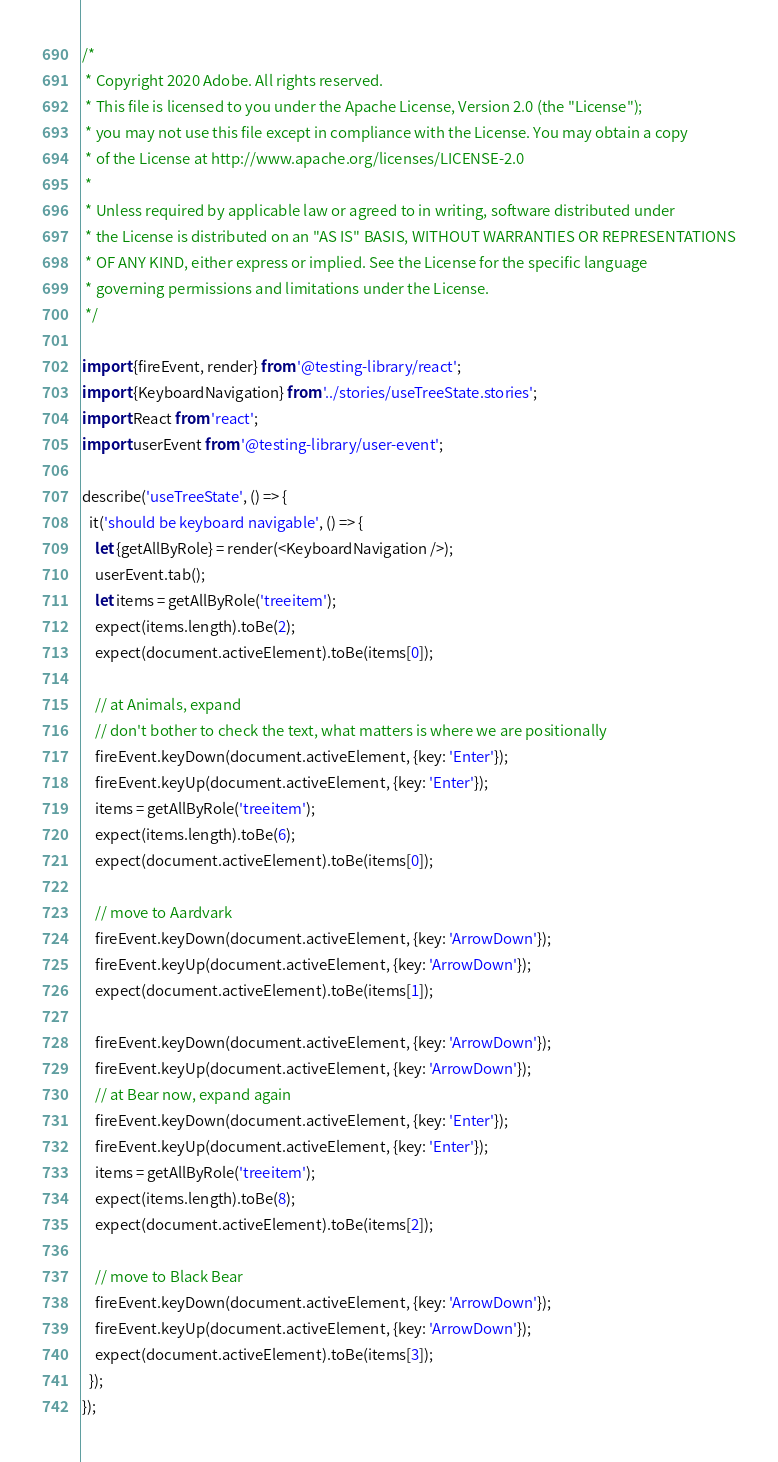Convert code to text. <code><loc_0><loc_0><loc_500><loc_500><_JavaScript_>/*
 * Copyright 2020 Adobe. All rights reserved.
 * This file is licensed to you under the Apache License, Version 2.0 (the "License");
 * you may not use this file except in compliance with the License. You may obtain a copy
 * of the License at http://www.apache.org/licenses/LICENSE-2.0
 *
 * Unless required by applicable law or agreed to in writing, software distributed under
 * the License is distributed on an "AS IS" BASIS, WITHOUT WARRANTIES OR REPRESENTATIONS
 * OF ANY KIND, either express or implied. See the License for the specific language
 * governing permissions and limitations under the License.
 */

import {fireEvent, render} from '@testing-library/react';
import {KeyboardNavigation} from '../stories/useTreeState.stories';
import React from 'react';
import userEvent from '@testing-library/user-event';

describe('useTreeState', () => {
  it('should be keyboard navigable', () => {
    let {getAllByRole} = render(<KeyboardNavigation />);
    userEvent.tab();
    let items = getAllByRole('treeitem');
    expect(items.length).toBe(2);
    expect(document.activeElement).toBe(items[0]);

    // at Animals, expand
    // don't bother to check the text, what matters is where we are positionally
    fireEvent.keyDown(document.activeElement, {key: 'Enter'});
    fireEvent.keyUp(document.activeElement, {key: 'Enter'});
    items = getAllByRole('treeitem');
    expect(items.length).toBe(6);
    expect(document.activeElement).toBe(items[0]);

    // move to Aardvark
    fireEvent.keyDown(document.activeElement, {key: 'ArrowDown'});
    fireEvent.keyUp(document.activeElement, {key: 'ArrowDown'});
    expect(document.activeElement).toBe(items[1]);

    fireEvent.keyDown(document.activeElement, {key: 'ArrowDown'});
    fireEvent.keyUp(document.activeElement, {key: 'ArrowDown'});
    // at Bear now, expand again
    fireEvent.keyDown(document.activeElement, {key: 'Enter'});
    fireEvent.keyUp(document.activeElement, {key: 'Enter'});
    items = getAllByRole('treeitem');
    expect(items.length).toBe(8);
    expect(document.activeElement).toBe(items[2]);

    // move to Black Bear
    fireEvent.keyDown(document.activeElement, {key: 'ArrowDown'});
    fireEvent.keyUp(document.activeElement, {key: 'ArrowDown'});
    expect(document.activeElement).toBe(items[3]);
  });
});
</code> 